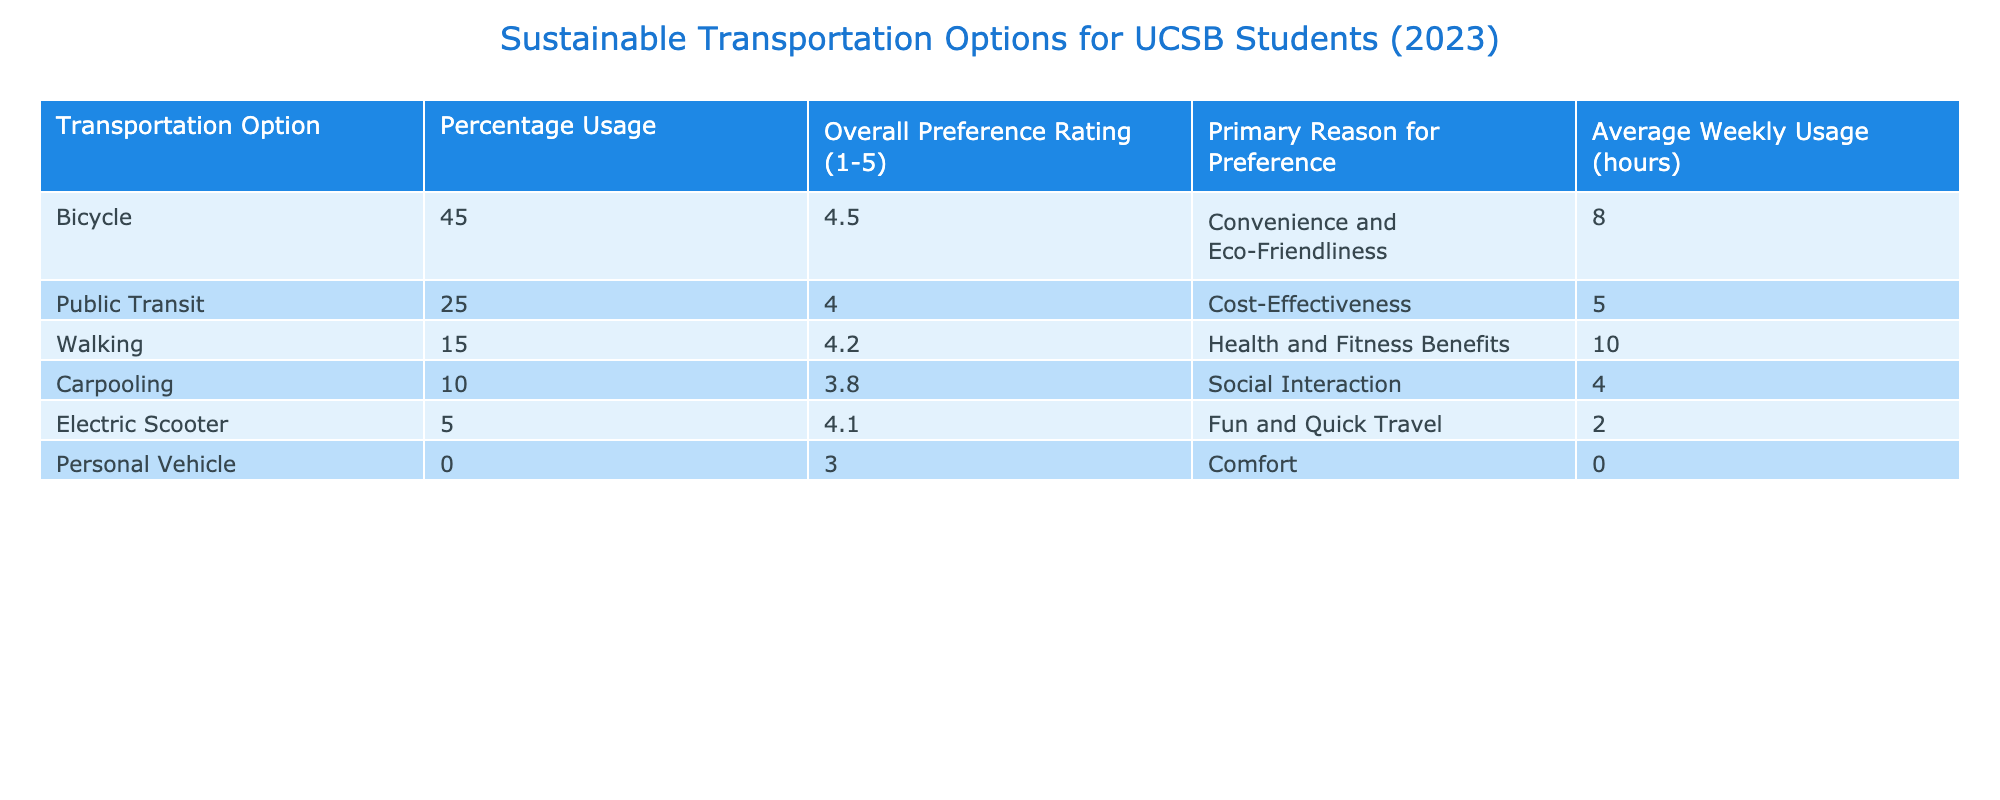What is the percentage usage of bicycles among UCSB students? The table shows a specific row for "Bicycle," where the percentage usage is listed directly. It states that the percentage usage is 45.
Answer: 45 Which transportation option has the highest overall preference rating? To find this, we need to look through the "Overall Preference Rating (1-5)" column. The highest value in that column is 4.5 for "Bicycle."
Answer: Bicycle Is the average weekly usage of public transit higher than that of carpooling? By examining the "Average Weekly Usage (hours)" column, public transit shows an average of 5 hours, while carpooling shows 4 hours. Since 5 is greater than 4, the statement is true.
Answer: Yes What is the average preference rating of walking and electric scooter usage combined? To find this, we sum the preference ratings for walking (4.2) and electric scooter (4.1), which yields 8.3. Then we divide by 2 (since there are two options) to get the average: 8.3 / 2 = 4.15.
Answer: 4.15 Does the table indicate that personal vehicles are preferred by students? The "Overall Preference Rating" for "Personal Vehicle" is 3.0 which is the lowest rating among all options in the table. This suggests low preference.
Answer: No What is the primary reason for preference for the option with the lowest percentage usage? The table shows that electric scooters have the lowest percentage usage at 5%. The primary reason for this preference is noted as "Fun and Quick Travel."
Answer: Fun and Quick Travel Calculate the difference in percentage usage between bicycles and carpooling. The percentage usage of bicycles is 45%, and for carpooling, it is 10%. The difference is calculated as 45 - 10 = 35.
Answer: 35 Which transportation option offers the best combination of high usage and preference rating? To analyze this, we can look for the option with both high percentage usage and high overall preference rating. Bicycles have an usage of 45% and preference of 4.5, making them the best option based on these criteria.
Answer: Bicycle 